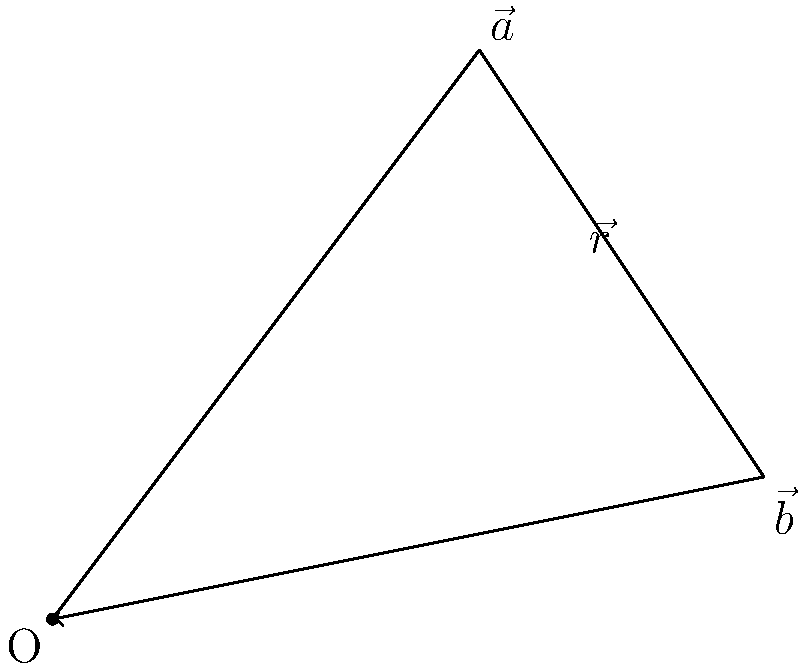In a workflow diagram representing two automated processes, vector $\vec{a}$ (3, 4) represents the efficiency gains from process A, and vector $\vec{b}$ (5, 1) represents the efficiency gains from process B. Calculate the magnitude of the resultant vector $\vec{r}$ that represents the combined efficiency gains of both processes. To find the magnitude of the resultant vector $\vec{r}$, we need to follow these steps:

1. Identify the components of both vectors:
   $\vec{a} = (3, 4)$ and $\vec{b} = (5, 1)$

2. Add the corresponding components to get the resultant vector $\vec{r}$:
   $\vec{r} = \vec{a} + \vec{b} = (3+5, 4+1) = (8, 5)$

3. Calculate the magnitude of $\vec{r}$ using the Pythagorean theorem:
   $|\vec{r}| = \sqrt{x^2 + y^2}$, where $x$ and $y$ are the components of $\vec{r}$

4. Substitute the values:
   $|\vec{r}| = \sqrt{8^2 + 5^2} = \sqrt{64 + 25} = \sqrt{89}$

5. Simplify:
   $|\vec{r}| = \sqrt{89} \approx 9.43$

Therefore, the magnitude of the resultant vector $\vec{r}$ is $\sqrt{89}$ or approximately 9.43 units.
Answer: $\sqrt{89}$ or $\approx 9.43$ units 